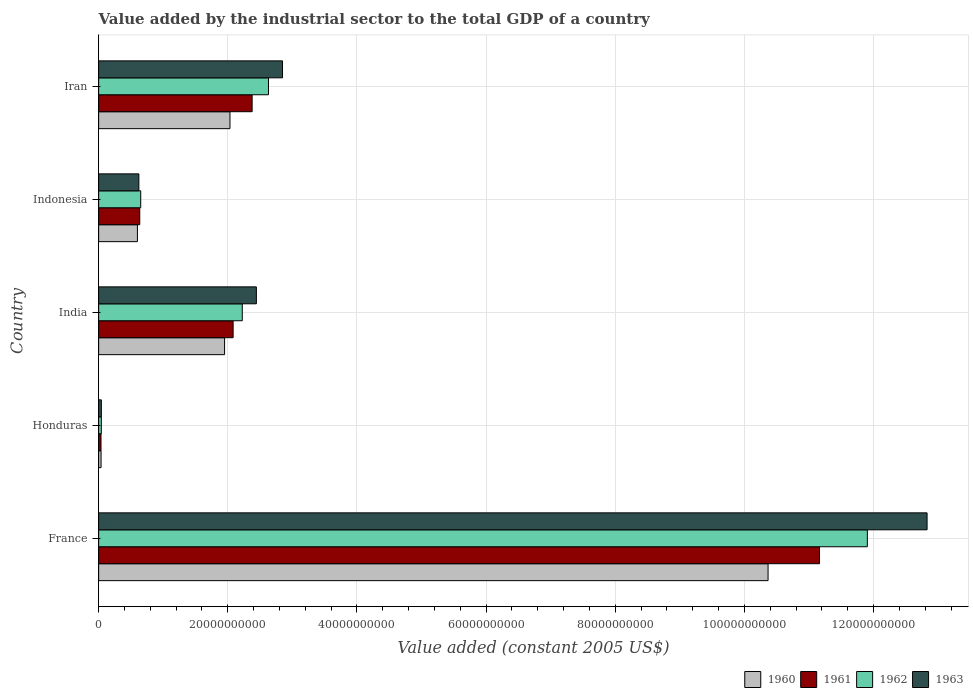How many different coloured bars are there?
Ensure brevity in your answer.  4. How many groups of bars are there?
Your answer should be very brief. 5. Are the number of bars per tick equal to the number of legend labels?
Give a very brief answer. Yes. How many bars are there on the 3rd tick from the top?
Offer a terse response. 4. What is the label of the 5th group of bars from the top?
Offer a very short reply. France. In how many cases, is the number of bars for a given country not equal to the number of legend labels?
Keep it short and to the point. 0. What is the value added by the industrial sector in 1961 in Indonesia?
Ensure brevity in your answer.  6.37e+09. Across all countries, what is the maximum value added by the industrial sector in 1963?
Offer a very short reply. 1.28e+11. Across all countries, what is the minimum value added by the industrial sector in 1963?
Ensure brevity in your answer.  4.23e+08. In which country was the value added by the industrial sector in 1960 maximum?
Ensure brevity in your answer.  France. In which country was the value added by the industrial sector in 1961 minimum?
Your answer should be compact. Honduras. What is the total value added by the industrial sector in 1963 in the graph?
Your response must be concise. 1.88e+11. What is the difference between the value added by the industrial sector in 1960 in Honduras and that in India?
Provide a succinct answer. -1.91e+1. What is the difference between the value added by the industrial sector in 1962 in India and the value added by the industrial sector in 1961 in Honduras?
Your answer should be compact. 2.19e+1. What is the average value added by the industrial sector in 1962 per country?
Your response must be concise. 3.49e+1. What is the difference between the value added by the industrial sector in 1960 and value added by the industrial sector in 1962 in India?
Ensure brevity in your answer.  -2.74e+09. In how many countries, is the value added by the industrial sector in 1960 greater than 92000000000 US$?
Your answer should be compact. 1. What is the ratio of the value added by the industrial sector in 1962 in Indonesia to that in Iran?
Keep it short and to the point. 0.25. Is the difference between the value added by the industrial sector in 1960 in India and Iran greater than the difference between the value added by the industrial sector in 1962 in India and Iran?
Provide a short and direct response. Yes. What is the difference between the highest and the second highest value added by the industrial sector in 1962?
Keep it short and to the point. 9.27e+1. What is the difference between the highest and the lowest value added by the industrial sector in 1962?
Make the answer very short. 1.19e+11. What does the 2nd bar from the top in Indonesia represents?
Provide a short and direct response. 1962. Is it the case that in every country, the sum of the value added by the industrial sector in 1962 and value added by the industrial sector in 1963 is greater than the value added by the industrial sector in 1960?
Your response must be concise. Yes. How many bars are there?
Your answer should be compact. 20. How many countries are there in the graph?
Provide a short and direct response. 5. Does the graph contain grids?
Your answer should be very brief. Yes. Where does the legend appear in the graph?
Your answer should be very brief. Bottom right. How are the legend labels stacked?
Keep it short and to the point. Horizontal. What is the title of the graph?
Provide a succinct answer. Value added by the industrial sector to the total GDP of a country. What is the label or title of the X-axis?
Ensure brevity in your answer.  Value added (constant 2005 US$). What is the Value added (constant 2005 US$) of 1960 in France?
Offer a very short reply. 1.04e+11. What is the Value added (constant 2005 US$) in 1961 in France?
Your response must be concise. 1.12e+11. What is the Value added (constant 2005 US$) in 1962 in France?
Provide a short and direct response. 1.19e+11. What is the Value added (constant 2005 US$) of 1963 in France?
Keep it short and to the point. 1.28e+11. What is the Value added (constant 2005 US$) in 1960 in Honduras?
Ensure brevity in your answer.  3.75e+08. What is the Value added (constant 2005 US$) in 1961 in Honduras?
Provide a succinct answer. 3.66e+08. What is the Value added (constant 2005 US$) in 1962 in Honduras?
Give a very brief answer. 4.16e+08. What is the Value added (constant 2005 US$) in 1963 in Honduras?
Provide a succinct answer. 4.23e+08. What is the Value added (constant 2005 US$) in 1960 in India?
Your response must be concise. 1.95e+1. What is the Value added (constant 2005 US$) of 1961 in India?
Your answer should be very brief. 2.08e+1. What is the Value added (constant 2005 US$) of 1962 in India?
Your answer should be compact. 2.22e+1. What is the Value added (constant 2005 US$) in 1963 in India?
Make the answer very short. 2.44e+1. What is the Value added (constant 2005 US$) of 1960 in Indonesia?
Your response must be concise. 6.01e+09. What is the Value added (constant 2005 US$) of 1961 in Indonesia?
Offer a terse response. 6.37e+09. What is the Value added (constant 2005 US$) of 1962 in Indonesia?
Your answer should be very brief. 6.52e+09. What is the Value added (constant 2005 US$) in 1963 in Indonesia?
Offer a very short reply. 6.23e+09. What is the Value added (constant 2005 US$) of 1960 in Iran?
Make the answer very short. 2.03e+1. What is the Value added (constant 2005 US$) of 1961 in Iran?
Your answer should be compact. 2.38e+1. What is the Value added (constant 2005 US$) of 1962 in Iran?
Ensure brevity in your answer.  2.63e+1. What is the Value added (constant 2005 US$) of 1963 in Iran?
Make the answer very short. 2.85e+1. Across all countries, what is the maximum Value added (constant 2005 US$) of 1960?
Your answer should be very brief. 1.04e+11. Across all countries, what is the maximum Value added (constant 2005 US$) of 1961?
Offer a very short reply. 1.12e+11. Across all countries, what is the maximum Value added (constant 2005 US$) in 1962?
Offer a very short reply. 1.19e+11. Across all countries, what is the maximum Value added (constant 2005 US$) of 1963?
Ensure brevity in your answer.  1.28e+11. Across all countries, what is the minimum Value added (constant 2005 US$) in 1960?
Offer a very short reply. 3.75e+08. Across all countries, what is the minimum Value added (constant 2005 US$) in 1961?
Provide a succinct answer. 3.66e+08. Across all countries, what is the minimum Value added (constant 2005 US$) in 1962?
Your answer should be compact. 4.16e+08. Across all countries, what is the minimum Value added (constant 2005 US$) of 1963?
Keep it short and to the point. 4.23e+08. What is the total Value added (constant 2005 US$) of 1960 in the graph?
Offer a very short reply. 1.50e+11. What is the total Value added (constant 2005 US$) of 1961 in the graph?
Keep it short and to the point. 1.63e+11. What is the total Value added (constant 2005 US$) of 1962 in the graph?
Your answer should be compact. 1.75e+11. What is the total Value added (constant 2005 US$) in 1963 in the graph?
Your answer should be very brief. 1.88e+11. What is the difference between the Value added (constant 2005 US$) of 1960 in France and that in Honduras?
Your answer should be compact. 1.03e+11. What is the difference between the Value added (constant 2005 US$) of 1961 in France and that in Honduras?
Give a very brief answer. 1.11e+11. What is the difference between the Value added (constant 2005 US$) of 1962 in France and that in Honduras?
Your response must be concise. 1.19e+11. What is the difference between the Value added (constant 2005 US$) of 1963 in France and that in Honduras?
Provide a short and direct response. 1.28e+11. What is the difference between the Value added (constant 2005 US$) in 1960 in France and that in India?
Ensure brevity in your answer.  8.42e+1. What is the difference between the Value added (constant 2005 US$) of 1961 in France and that in India?
Offer a very short reply. 9.08e+1. What is the difference between the Value added (constant 2005 US$) of 1962 in France and that in India?
Your response must be concise. 9.68e+1. What is the difference between the Value added (constant 2005 US$) in 1963 in France and that in India?
Give a very brief answer. 1.04e+11. What is the difference between the Value added (constant 2005 US$) in 1960 in France and that in Indonesia?
Offer a very short reply. 9.77e+1. What is the difference between the Value added (constant 2005 US$) in 1961 in France and that in Indonesia?
Your response must be concise. 1.05e+11. What is the difference between the Value added (constant 2005 US$) in 1962 in France and that in Indonesia?
Your answer should be very brief. 1.13e+11. What is the difference between the Value added (constant 2005 US$) of 1963 in France and that in Indonesia?
Your response must be concise. 1.22e+11. What is the difference between the Value added (constant 2005 US$) in 1960 in France and that in Iran?
Ensure brevity in your answer.  8.33e+1. What is the difference between the Value added (constant 2005 US$) in 1961 in France and that in Iran?
Offer a terse response. 8.79e+1. What is the difference between the Value added (constant 2005 US$) of 1962 in France and that in Iran?
Your answer should be very brief. 9.27e+1. What is the difference between the Value added (constant 2005 US$) in 1963 in France and that in Iran?
Keep it short and to the point. 9.98e+1. What is the difference between the Value added (constant 2005 US$) of 1960 in Honduras and that in India?
Make the answer very short. -1.91e+1. What is the difference between the Value added (constant 2005 US$) in 1961 in Honduras and that in India?
Offer a terse response. -2.05e+1. What is the difference between the Value added (constant 2005 US$) of 1962 in Honduras and that in India?
Provide a succinct answer. -2.18e+1. What is the difference between the Value added (constant 2005 US$) of 1963 in Honduras and that in India?
Provide a succinct answer. -2.40e+1. What is the difference between the Value added (constant 2005 US$) of 1960 in Honduras and that in Indonesia?
Give a very brief answer. -5.63e+09. What is the difference between the Value added (constant 2005 US$) of 1961 in Honduras and that in Indonesia?
Provide a succinct answer. -6.00e+09. What is the difference between the Value added (constant 2005 US$) in 1962 in Honduras and that in Indonesia?
Offer a terse response. -6.10e+09. What is the difference between the Value added (constant 2005 US$) in 1963 in Honduras and that in Indonesia?
Keep it short and to the point. -5.81e+09. What is the difference between the Value added (constant 2005 US$) in 1960 in Honduras and that in Iran?
Offer a terse response. -2.00e+1. What is the difference between the Value added (constant 2005 US$) of 1961 in Honduras and that in Iran?
Provide a succinct answer. -2.34e+1. What is the difference between the Value added (constant 2005 US$) of 1962 in Honduras and that in Iran?
Give a very brief answer. -2.59e+1. What is the difference between the Value added (constant 2005 US$) in 1963 in Honduras and that in Iran?
Your answer should be compact. -2.81e+1. What is the difference between the Value added (constant 2005 US$) of 1960 in India and that in Indonesia?
Provide a short and direct response. 1.35e+1. What is the difference between the Value added (constant 2005 US$) in 1961 in India and that in Indonesia?
Give a very brief answer. 1.45e+1. What is the difference between the Value added (constant 2005 US$) of 1962 in India and that in Indonesia?
Keep it short and to the point. 1.57e+1. What is the difference between the Value added (constant 2005 US$) in 1963 in India and that in Indonesia?
Your response must be concise. 1.82e+1. What is the difference between the Value added (constant 2005 US$) in 1960 in India and that in Iran?
Make the answer very short. -8.36e+08. What is the difference between the Value added (constant 2005 US$) in 1961 in India and that in Iran?
Provide a short and direct response. -2.94e+09. What is the difference between the Value added (constant 2005 US$) of 1962 in India and that in Iran?
Make the answer very short. -4.06e+09. What is the difference between the Value added (constant 2005 US$) in 1963 in India and that in Iran?
Offer a very short reply. -4.05e+09. What is the difference between the Value added (constant 2005 US$) of 1960 in Indonesia and that in Iran?
Make the answer very short. -1.43e+1. What is the difference between the Value added (constant 2005 US$) in 1961 in Indonesia and that in Iran?
Your answer should be compact. -1.74e+1. What is the difference between the Value added (constant 2005 US$) in 1962 in Indonesia and that in Iran?
Ensure brevity in your answer.  -1.98e+1. What is the difference between the Value added (constant 2005 US$) of 1963 in Indonesia and that in Iran?
Ensure brevity in your answer.  -2.22e+1. What is the difference between the Value added (constant 2005 US$) in 1960 in France and the Value added (constant 2005 US$) in 1961 in Honduras?
Make the answer very short. 1.03e+11. What is the difference between the Value added (constant 2005 US$) in 1960 in France and the Value added (constant 2005 US$) in 1962 in Honduras?
Provide a short and direct response. 1.03e+11. What is the difference between the Value added (constant 2005 US$) in 1960 in France and the Value added (constant 2005 US$) in 1963 in Honduras?
Provide a short and direct response. 1.03e+11. What is the difference between the Value added (constant 2005 US$) in 1961 in France and the Value added (constant 2005 US$) in 1962 in Honduras?
Your answer should be very brief. 1.11e+11. What is the difference between the Value added (constant 2005 US$) in 1961 in France and the Value added (constant 2005 US$) in 1963 in Honduras?
Ensure brevity in your answer.  1.11e+11. What is the difference between the Value added (constant 2005 US$) in 1962 in France and the Value added (constant 2005 US$) in 1963 in Honduras?
Provide a succinct answer. 1.19e+11. What is the difference between the Value added (constant 2005 US$) in 1960 in France and the Value added (constant 2005 US$) in 1961 in India?
Offer a very short reply. 8.28e+1. What is the difference between the Value added (constant 2005 US$) in 1960 in France and the Value added (constant 2005 US$) in 1962 in India?
Provide a short and direct response. 8.14e+1. What is the difference between the Value added (constant 2005 US$) in 1960 in France and the Value added (constant 2005 US$) in 1963 in India?
Your answer should be compact. 7.92e+1. What is the difference between the Value added (constant 2005 US$) of 1961 in France and the Value added (constant 2005 US$) of 1962 in India?
Your response must be concise. 8.94e+1. What is the difference between the Value added (constant 2005 US$) in 1961 in France and the Value added (constant 2005 US$) in 1963 in India?
Keep it short and to the point. 8.72e+1. What is the difference between the Value added (constant 2005 US$) of 1962 in France and the Value added (constant 2005 US$) of 1963 in India?
Provide a succinct answer. 9.46e+1. What is the difference between the Value added (constant 2005 US$) in 1960 in France and the Value added (constant 2005 US$) in 1961 in Indonesia?
Offer a terse response. 9.73e+1. What is the difference between the Value added (constant 2005 US$) of 1960 in France and the Value added (constant 2005 US$) of 1962 in Indonesia?
Give a very brief answer. 9.71e+1. What is the difference between the Value added (constant 2005 US$) of 1960 in France and the Value added (constant 2005 US$) of 1963 in Indonesia?
Your response must be concise. 9.74e+1. What is the difference between the Value added (constant 2005 US$) in 1961 in France and the Value added (constant 2005 US$) in 1962 in Indonesia?
Provide a short and direct response. 1.05e+11. What is the difference between the Value added (constant 2005 US$) of 1961 in France and the Value added (constant 2005 US$) of 1963 in Indonesia?
Your answer should be very brief. 1.05e+11. What is the difference between the Value added (constant 2005 US$) in 1962 in France and the Value added (constant 2005 US$) in 1963 in Indonesia?
Ensure brevity in your answer.  1.13e+11. What is the difference between the Value added (constant 2005 US$) in 1960 in France and the Value added (constant 2005 US$) in 1961 in Iran?
Give a very brief answer. 7.99e+1. What is the difference between the Value added (constant 2005 US$) in 1960 in France and the Value added (constant 2005 US$) in 1962 in Iran?
Make the answer very short. 7.74e+1. What is the difference between the Value added (constant 2005 US$) in 1960 in France and the Value added (constant 2005 US$) in 1963 in Iran?
Provide a short and direct response. 7.52e+1. What is the difference between the Value added (constant 2005 US$) in 1961 in France and the Value added (constant 2005 US$) in 1962 in Iran?
Provide a succinct answer. 8.53e+1. What is the difference between the Value added (constant 2005 US$) in 1961 in France and the Value added (constant 2005 US$) in 1963 in Iran?
Give a very brief answer. 8.32e+1. What is the difference between the Value added (constant 2005 US$) in 1962 in France and the Value added (constant 2005 US$) in 1963 in Iran?
Provide a short and direct response. 9.06e+1. What is the difference between the Value added (constant 2005 US$) of 1960 in Honduras and the Value added (constant 2005 US$) of 1961 in India?
Ensure brevity in your answer.  -2.05e+1. What is the difference between the Value added (constant 2005 US$) of 1960 in Honduras and the Value added (constant 2005 US$) of 1962 in India?
Your response must be concise. -2.19e+1. What is the difference between the Value added (constant 2005 US$) of 1960 in Honduras and the Value added (constant 2005 US$) of 1963 in India?
Make the answer very short. -2.41e+1. What is the difference between the Value added (constant 2005 US$) in 1961 in Honduras and the Value added (constant 2005 US$) in 1962 in India?
Give a very brief answer. -2.19e+1. What is the difference between the Value added (constant 2005 US$) in 1961 in Honduras and the Value added (constant 2005 US$) in 1963 in India?
Give a very brief answer. -2.41e+1. What is the difference between the Value added (constant 2005 US$) of 1962 in Honduras and the Value added (constant 2005 US$) of 1963 in India?
Ensure brevity in your answer.  -2.40e+1. What is the difference between the Value added (constant 2005 US$) in 1960 in Honduras and the Value added (constant 2005 US$) in 1961 in Indonesia?
Provide a short and direct response. -5.99e+09. What is the difference between the Value added (constant 2005 US$) of 1960 in Honduras and the Value added (constant 2005 US$) of 1962 in Indonesia?
Keep it short and to the point. -6.14e+09. What is the difference between the Value added (constant 2005 US$) in 1960 in Honduras and the Value added (constant 2005 US$) in 1963 in Indonesia?
Your answer should be compact. -5.85e+09. What is the difference between the Value added (constant 2005 US$) of 1961 in Honduras and the Value added (constant 2005 US$) of 1962 in Indonesia?
Your response must be concise. -6.15e+09. What is the difference between the Value added (constant 2005 US$) in 1961 in Honduras and the Value added (constant 2005 US$) in 1963 in Indonesia?
Provide a short and direct response. -5.86e+09. What is the difference between the Value added (constant 2005 US$) of 1962 in Honduras and the Value added (constant 2005 US$) of 1963 in Indonesia?
Give a very brief answer. -5.81e+09. What is the difference between the Value added (constant 2005 US$) in 1960 in Honduras and the Value added (constant 2005 US$) in 1961 in Iran?
Your answer should be compact. -2.34e+1. What is the difference between the Value added (constant 2005 US$) in 1960 in Honduras and the Value added (constant 2005 US$) in 1962 in Iran?
Your response must be concise. -2.59e+1. What is the difference between the Value added (constant 2005 US$) of 1960 in Honduras and the Value added (constant 2005 US$) of 1963 in Iran?
Your answer should be compact. -2.81e+1. What is the difference between the Value added (constant 2005 US$) of 1961 in Honduras and the Value added (constant 2005 US$) of 1962 in Iran?
Give a very brief answer. -2.59e+1. What is the difference between the Value added (constant 2005 US$) in 1961 in Honduras and the Value added (constant 2005 US$) in 1963 in Iran?
Keep it short and to the point. -2.81e+1. What is the difference between the Value added (constant 2005 US$) of 1962 in Honduras and the Value added (constant 2005 US$) of 1963 in Iran?
Your response must be concise. -2.81e+1. What is the difference between the Value added (constant 2005 US$) of 1960 in India and the Value added (constant 2005 US$) of 1961 in Indonesia?
Make the answer very short. 1.31e+1. What is the difference between the Value added (constant 2005 US$) in 1960 in India and the Value added (constant 2005 US$) in 1962 in Indonesia?
Offer a terse response. 1.30e+1. What is the difference between the Value added (constant 2005 US$) of 1960 in India and the Value added (constant 2005 US$) of 1963 in Indonesia?
Your answer should be very brief. 1.33e+1. What is the difference between the Value added (constant 2005 US$) in 1961 in India and the Value added (constant 2005 US$) in 1962 in Indonesia?
Your response must be concise. 1.43e+1. What is the difference between the Value added (constant 2005 US$) in 1961 in India and the Value added (constant 2005 US$) in 1963 in Indonesia?
Give a very brief answer. 1.46e+1. What is the difference between the Value added (constant 2005 US$) in 1962 in India and the Value added (constant 2005 US$) in 1963 in Indonesia?
Your answer should be very brief. 1.60e+1. What is the difference between the Value added (constant 2005 US$) in 1960 in India and the Value added (constant 2005 US$) in 1961 in Iran?
Offer a very short reply. -4.27e+09. What is the difference between the Value added (constant 2005 US$) of 1960 in India and the Value added (constant 2005 US$) of 1962 in Iran?
Your response must be concise. -6.80e+09. What is the difference between the Value added (constant 2005 US$) of 1960 in India and the Value added (constant 2005 US$) of 1963 in Iran?
Give a very brief answer. -8.97e+09. What is the difference between the Value added (constant 2005 US$) in 1961 in India and the Value added (constant 2005 US$) in 1962 in Iran?
Provide a succinct answer. -5.48e+09. What is the difference between the Value added (constant 2005 US$) of 1961 in India and the Value added (constant 2005 US$) of 1963 in Iran?
Your answer should be very brief. -7.65e+09. What is the difference between the Value added (constant 2005 US$) of 1962 in India and the Value added (constant 2005 US$) of 1963 in Iran?
Ensure brevity in your answer.  -6.23e+09. What is the difference between the Value added (constant 2005 US$) in 1960 in Indonesia and the Value added (constant 2005 US$) in 1961 in Iran?
Make the answer very short. -1.78e+1. What is the difference between the Value added (constant 2005 US$) of 1960 in Indonesia and the Value added (constant 2005 US$) of 1962 in Iran?
Your answer should be very brief. -2.03e+1. What is the difference between the Value added (constant 2005 US$) in 1960 in Indonesia and the Value added (constant 2005 US$) in 1963 in Iran?
Make the answer very short. -2.25e+1. What is the difference between the Value added (constant 2005 US$) of 1961 in Indonesia and the Value added (constant 2005 US$) of 1962 in Iran?
Your response must be concise. -1.99e+1. What is the difference between the Value added (constant 2005 US$) of 1961 in Indonesia and the Value added (constant 2005 US$) of 1963 in Iran?
Your answer should be very brief. -2.21e+1. What is the difference between the Value added (constant 2005 US$) in 1962 in Indonesia and the Value added (constant 2005 US$) in 1963 in Iran?
Offer a very short reply. -2.20e+1. What is the average Value added (constant 2005 US$) of 1960 per country?
Ensure brevity in your answer.  3.00e+1. What is the average Value added (constant 2005 US$) of 1961 per country?
Provide a succinct answer. 3.26e+1. What is the average Value added (constant 2005 US$) of 1962 per country?
Offer a very short reply. 3.49e+1. What is the average Value added (constant 2005 US$) in 1963 per country?
Offer a very short reply. 3.76e+1. What is the difference between the Value added (constant 2005 US$) of 1960 and Value added (constant 2005 US$) of 1961 in France?
Your answer should be very brief. -7.97e+09. What is the difference between the Value added (constant 2005 US$) of 1960 and Value added (constant 2005 US$) of 1962 in France?
Provide a succinct answer. -1.54e+1. What is the difference between the Value added (constant 2005 US$) in 1960 and Value added (constant 2005 US$) in 1963 in France?
Offer a terse response. -2.46e+1. What is the difference between the Value added (constant 2005 US$) of 1961 and Value added (constant 2005 US$) of 1962 in France?
Provide a succinct answer. -7.41e+09. What is the difference between the Value added (constant 2005 US$) in 1961 and Value added (constant 2005 US$) in 1963 in France?
Your response must be concise. -1.67e+1. What is the difference between the Value added (constant 2005 US$) in 1962 and Value added (constant 2005 US$) in 1963 in France?
Ensure brevity in your answer.  -9.25e+09. What is the difference between the Value added (constant 2005 US$) of 1960 and Value added (constant 2005 US$) of 1961 in Honduras?
Ensure brevity in your answer.  9.37e+06. What is the difference between the Value added (constant 2005 US$) of 1960 and Value added (constant 2005 US$) of 1962 in Honduras?
Provide a succinct answer. -4.07e+07. What is the difference between the Value added (constant 2005 US$) of 1960 and Value added (constant 2005 US$) of 1963 in Honduras?
Your response must be concise. -4.79e+07. What is the difference between the Value added (constant 2005 US$) in 1961 and Value added (constant 2005 US$) in 1962 in Honduras?
Keep it short and to the point. -5.00e+07. What is the difference between the Value added (constant 2005 US$) of 1961 and Value added (constant 2005 US$) of 1963 in Honduras?
Keep it short and to the point. -5.72e+07. What is the difference between the Value added (constant 2005 US$) of 1962 and Value added (constant 2005 US$) of 1963 in Honduras?
Offer a very short reply. -7.19e+06. What is the difference between the Value added (constant 2005 US$) of 1960 and Value added (constant 2005 US$) of 1961 in India?
Make the answer very short. -1.32e+09. What is the difference between the Value added (constant 2005 US$) of 1960 and Value added (constant 2005 US$) of 1962 in India?
Make the answer very short. -2.74e+09. What is the difference between the Value added (constant 2005 US$) in 1960 and Value added (constant 2005 US$) in 1963 in India?
Offer a very short reply. -4.92e+09. What is the difference between the Value added (constant 2005 US$) in 1961 and Value added (constant 2005 US$) in 1962 in India?
Provide a short and direct response. -1.42e+09. What is the difference between the Value added (constant 2005 US$) of 1961 and Value added (constant 2005 US$) of 1963 in India?
Make the answer very short. -3.60e+09. What is the difference between the Value added (constant 2005 US$) in 1962 and Value added (constant 2005 US$) in 1963 in India?
Provide a short and direct response. -2.18e+09. What is the difference between the Value added (constant 2005 US$) of 1960 and Value added (constant 2005 US$) of 1961 in Indonesia?
Ensure brevity in your answer.  -3.60e+08. What is the difference between the Value added (constant 2005 US$) of 1960 and Value added (constant 2005 US$) of 1962 in Indonesia?
Your response must be concise. -5.10e+08. What is the difference between the Value added (constant 2005 US$) in 1960 and Value added (constant 2005 US$) in 1963 in Indonesia?
Your answer should be compact. -2.22e+08. What is the difference between the Value added (constant 2005 US$) in 1961 and Value added (constant 2005 US$) in 1962 in Indonesia?
Provide a succinct answer. -1.50e+08. What is the difference between the Value added (constant 2005 US$) of 1961 and Value added (constant 2005 US$) of 1963 in Indonesia?
Ensure brevity in your answer.  1.38e+08. What is the difference between the Value added (constant 2005 US$) in 1962 and Value added (constant 2005 US$) in 1963 in Indonesia?
Provide a succinct answer. 2.88e+08. What is the difference between the Value added (constant 2005 US$) in 1960 and Value added (constant 2005 US$) in 1961 in Iran?
Offer a very short reply. -3.43e+09. What is the difference between the Value added (constant 2005 US$) in 1960 and Value added (constant 2005 US$) in 1962 in Iran?
Keep it short and to the point. -5.96e+09. What is the difference between the Value added (constant 2005 US$) in 1960 and Value added (constant 2005 US$) in 1963 in Iran?
Make the answer very short. -8.14e+09. What is the difference between the Value added (constant 2005 US$) of 1961 and Value added (constant 2005 US$) of 1962 in Iran?
Give a very brief answer. -2.53e+09. What is the difference between the Value added (constant 2005 US$) in 1961 and Value added (constant 2005 US$) in 1963 in Iran?
Make the answer very short. -4.71e+09. What is the difference between the Value added (constant 2005 US$) of 1962 and Value added (constant 2005 US$) of 1963 in Iran?
Your answer should be very brief. -2.17e+09. What is the ratio of the Value added (constant 2005 US$) in 1960 in France to that in Honduras?
Offer a very short reply. 276.31. What is the ratio of the Value added (constant 2005 US$) in 1961 in France to that in Honduras?
Your answer should be very brief. 305.16. What is the ratio of the Value added (constant 2005 US$) in 1962 in France to that in Honduras?
Make the answer very short. 286.26. What is the ratio of the Value added (constant 2005 US$) of 1963 in France to that in Honduras?
Ensure brevity in your answer.  303.25. What is the ratio of the Value added (constant 2005 US$) of 1960 in France to that in India?
Provide a short and direct response. 5.32. What is the ratio of the Value added (constant 2005 US$) of 1961 in France to that in India?
Give a very brief answer. 5.36. What is the ratio of the Value added (constant 2005 US$) of 1962 in France to that in India?
Your answer should be very brief. 5.35. What is the ratio of the Value added (constant 2005 US$) in 1963 in France to that in India?
Make the answer very short. 5.25. What is the ratio of the Value added (constant 2005 US$) in 1960 in France to that in Indonesia?
Give a very brief answer. 17.26. What is the ratio of the Value added (constant 2005 US$) of 1961 in France to that in Indonesia?
Ensure brevity in your answer.  17.53. What is the ratio of the Value added (constant 2005 US$) in 1962 in France to that in Indonesia?
Give a very brief answer. 18.27. What is the ratio of the Value added (constant 2005 US$) of 1963 in France to that in Indonesia?
Offer a very short reply. 20.59. What is the ratio of the Value added (constant 2005 US$) of 1960 in France to that in Iran?
Your response must be concise. 5.1. What is the ratio of the Value added (constant 2005 US$) of 1961 in France to that in Iran?
Your answer should be compact. 4.7. What is the ratio of the Value added (constant 2005 US$) of 1962 in France to that in Iran?
Keep it short and to the point. 4.53. What is the ratio of the Value added (constant 2005 US$) in 1963 in France to that in Iran?
Your response must be concise. 4.51. What is the ratio of the Value added (constant 2005 US$) of 1960 in Honduras to that in India?
Offer a terse response. 0.02. What is the ratio of the Value added (constant 2005 US$) in 1961 in Honduras to that in India?
Provide a short and direct response. 0.02. What is the ratio of the Value added (constant 2005 US$) in 1962 in Honduras to that in India?
Give a very brief answer. 0.02. What is the ratio of the Value added (constant 2005 US$) in 1963 in Honduras to that in India?
Your answer should be very brief. 0.02. What is the ratio of the Value added (constant 2005 US$) of 1960 in Honduras to that in Indonesia?
Offer a very short reply. 0.06. What is the ratio of the Value added (constant 2005 US$) in 1961 in Honduras to that in Indonesia?
Offer a terse response. 0.06. What is the ratio of the Value added (constant 2005 US$) in 1962 in Honduras to that in Indonesia?
Your answer should be compact. 0.06. What is the ratio of the Value added (constant 2005 US$) in 1963 in Honduras to that in Indonesia?
Ensure brevity in your answer.  0.07. What is the ratio of the Value added (constant 2005 US$) of 1960 in Honduras to that in Iran?
Offer a terse response. 0.02. What is the ratio of the Value added (constant 2005 US$) in 1961 in Honduras to that in Iran?
Offer a terse response. 0.02. What is the ratio of the Value added (constant 2005 US$) of 1962 in Honduras to that in Iran?
Make the answer very short. 0.02. What is the ratio of the Value added (constant 2005 US$) of 1963 in Honduras to that in Iran?
Make the answer very short. 0.01. What is the ratio of the Value added (constant 2005 US$) of 1960 in India to that in Indonesia?
Offer a terse response. 3.25. What is the ratio of the Value added (constant 2005 US$) in 1961 in India to that in Indonesia?
Your response must be concise. 3.27. What is the ratio of the Value added (constant 2005 US$) of 1962 in India to that in Indonesia?
Provide a succinct answer. 3.41. What is the ratio of the Value added (constant 2005 US$) of 1963 in India to that in Indonesia?
Keep it short and to the point. 3.92. What is the ratio of the Value added (constant 2005 US$) in 1960 in India to that in Iran?
Provide a short and direct response. 0.96. What is the ratio of the Value added (constant 2005 US$) in 1961 in India to that in Iran?
Give a very brief answer. 0.88. What is the ratio of the Value added (constant 2005 US$) in 1962 in India to that in Iran?
Your answer should be compact. 0.85. What is the ratio of the Value added (constant 2005 US$) of 1963 in India to that in Iran?
Give a very brief answer. 0.86. What is the ratio of the Value added (constant 2005 US$) in 1960 in Indonesia to that in Iran?
Make the answer very short. 0.3. What is the ratio of the Value added (constant 2005 US$) of 1961 in Indonesia to that in Iran?
Your response must be concise. 0.27. What is the ratio of the Value added (constant 2005 US$) of 1962 in Indonesia to that in Iran?
Provide a succinct answer. 0.25. What is the ratio of the Value added (constant 2005 US$) of 1963 in Indonesia to that in Iran?
Provide a short and direct response. 0.22. What is the difference between the highest and the second highest Value added (constant 2005 US$) of 1960?
Give a very brief answer. 8.33e+1. What is the difference between the highest and the second highest Value added (constant 2005 US$) of 1961?
Ensure brevity in your answer.  8.79e+1. What is the difference between the highest and the second highest Value added (constant 2005 US$) in 1962?
Your answer should be very brief. 9.27e+1. What is the difference between the highest and the second highest Value added (constant 2005 US$) of 1963?
Your answer should be very brief. 9.98e+1. What is the difference between the highest and the lowest Value added (constant 2005 US$) in 1960?
Ensure brevity in your answer.  1.03e+11. What is the difference between the highest and the lowest Value added (constant 2005 US$) of 1961?
Your answer should be compact. 1.11e+11. What is the difference between the highest and the lowest Value added (constant 2005 US$) in 1962?
Offer a terse response. 1.19e+11. What is the difference between the highest and the lowest Value added (constant 2005 US$) in 1963?
Provide a short and direct response. 1.28e+11. 